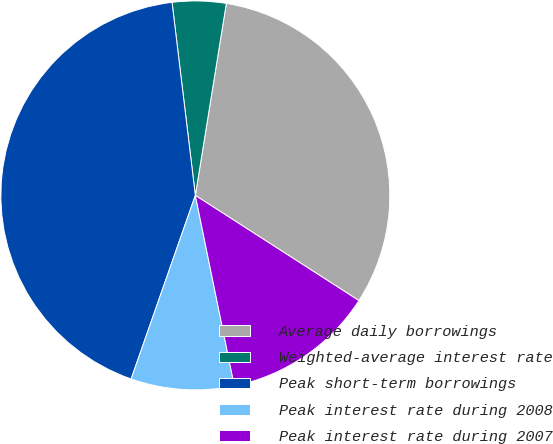<chart> <loc_0><loc_0><loc_500><loc_500><pie_chart><fcel>Average daily borrowings<fcel>Weighted-average interest rate<fcel>Peak short-term borrowings<fcel>Peak interest rate during 2008<fcel>Peak interest rate during 2007<nl><fcel>31.55%<fcel>4.46%<fcel>42.73%<fcel>8.57%<fcel>12.69%<nl></chart> 